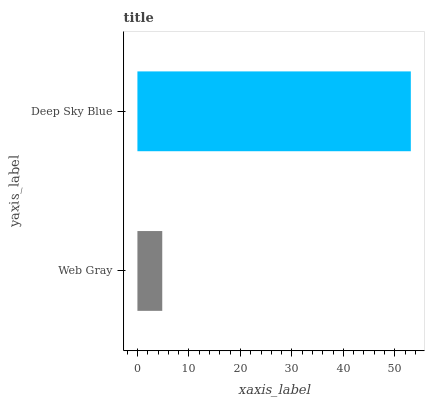Is Web Gray the minimum?
Answer yes or no. Yes. Is Deep Sky Blue the maximum?
Answer yes or no. Yes. Is Deep Sky Blue the minimum?
Answer yes or no. No. Is Deep Sky Blue greater than Web Gray?
Answer yes or no. Yes. Is Web Gray less than Deep Sky Blue?
Answer yes or no. Yes. Is Web Gray greater than Deep Sky Blue?
Answer yes or no. No. Is Deep Sky Blue less than Web Gray?
Answer yes or no. No. Is Deep Sky Blue the high median?
Answer yes or no. Yes. Is Web Gray the low median?
Answer yes or no. Yes. Is Web Gray the high median?
Answer yes or no. No. Is Deep Sky Blue the low median?
Answer yes or no. No. 